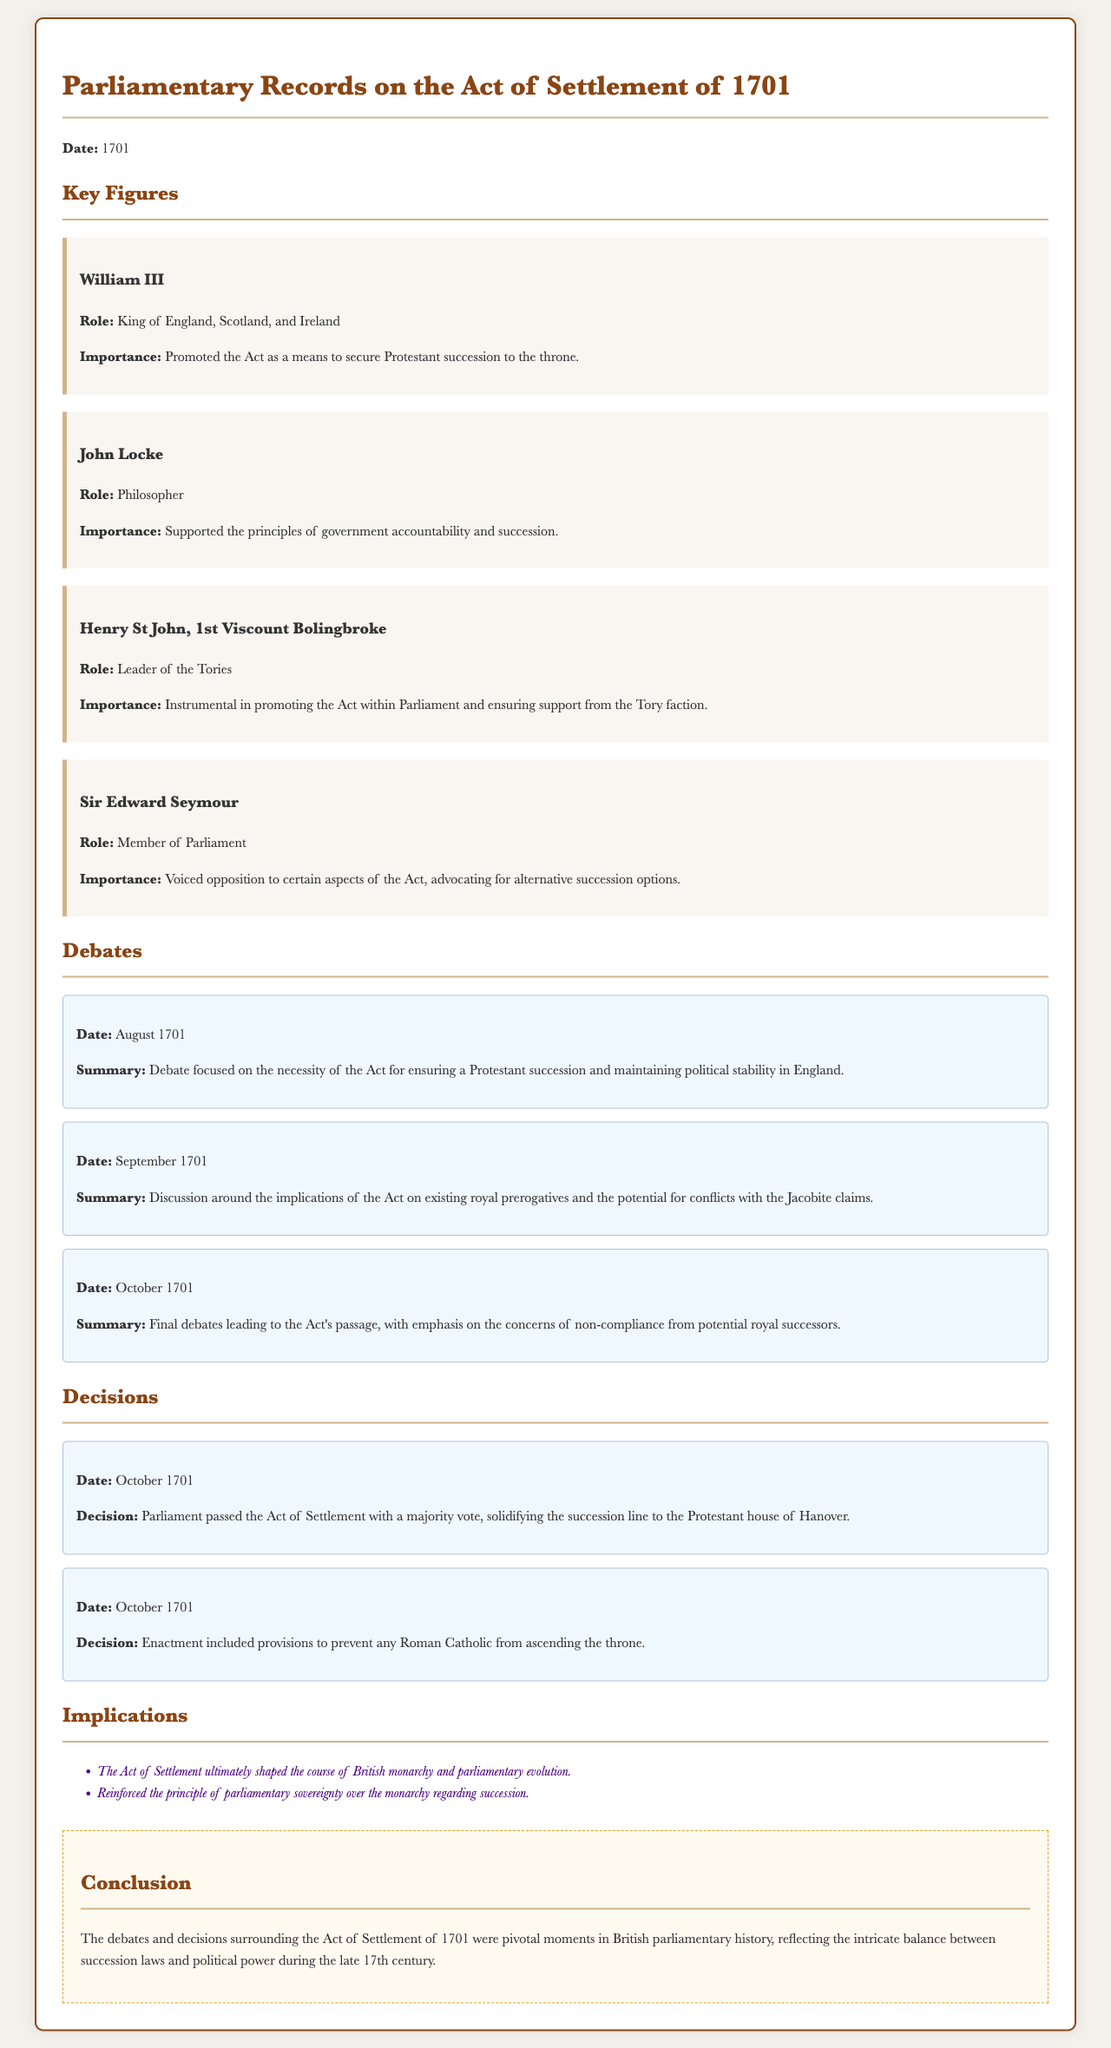What is the date of the Act of Settlement? The document specifies that the Act of Settlement was discussed in the year 1701.
Answer: 1701 Who was the King of England during the Act of Settlement debates? The document mentions William III, who was noted as the King of England, Scotland, and Ireland.
Answer: William III What role did Henry St John, 1st Viscount Bolingbroke, play in the Act of Settlement? According to the document, he was the Leader of the Tories and instrumental in promoting the Act within Parliament.
Answer: Leader of the Tories In what month did the final debates leading to the Act's passage occur? The document indicates that these final debates took place in October 1701.
Answer: October What was one of the decisions made on October 1701 regarding the Act? The document states that Parliament passed the Act with a majority vote.
Answer: Majority vote What was a key implication of the Act of Settlement noted in the document? The document outlines that the Act ultimately shaped the course of British monarchy and parliamentary evolution.
Answer: Shaped the course of British monarchy What philosophical principle did John Locke support in relation to the Act of Settlement? The document highlights that John Locke supported the principles of government accountability and succession.
Answer: Government accountability and succession What was a concern addressed in the debates regarding the Act? The summary of the debates mentions concerns about non-compliance from potential royal successors.
Answer: Non-compliance from potential royal successors Who voiced opposition to the Act according to the document? The document indicates that Sir Edward Seymour voiced opposition to certain aspects of the Act.
Answer: Sir Edward Seymour 